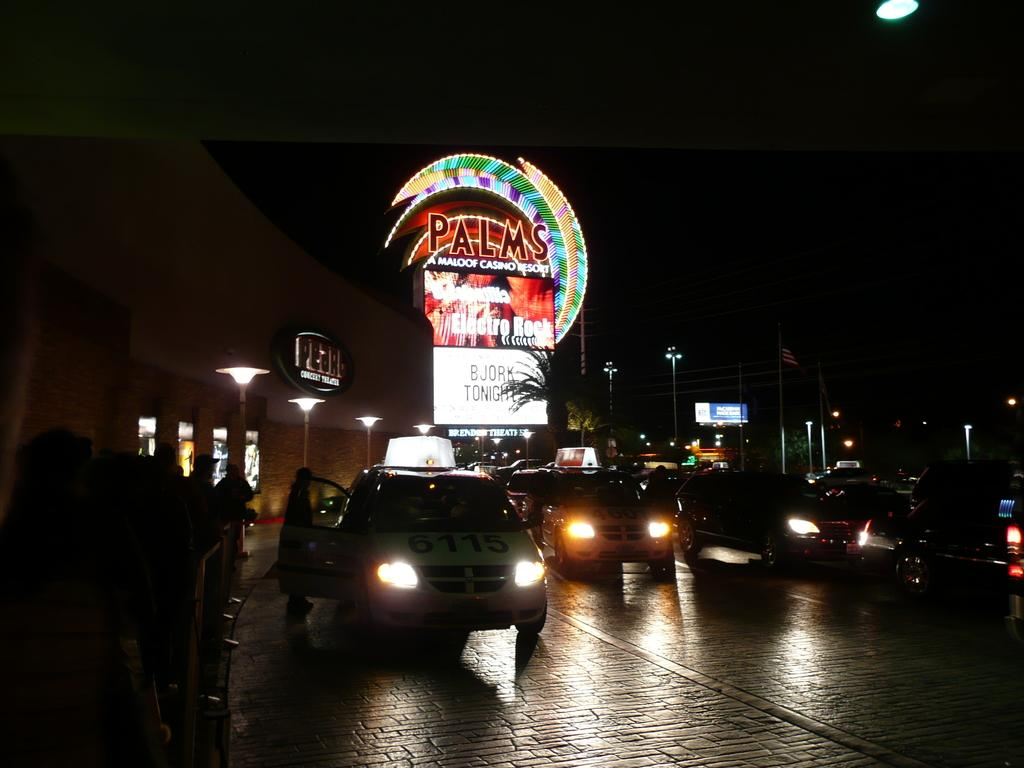<image>
Write a terse but informative summary of the picture. A large neon sign that says Palms resort casino. 